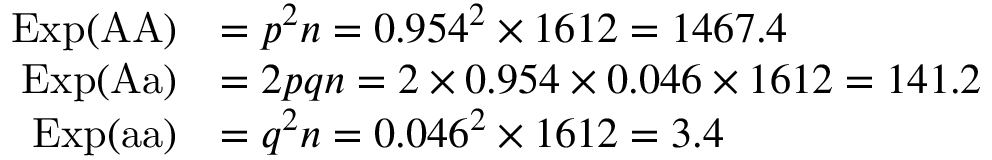Convert formula to latex. <formula><loc_0><loc_0><loc_500><loc_500>{ \begin{array} { r l } { E x p ( { A A } ) } & { = p ^ { 2 } n = 0 . 9 5 4 ^ { 2 } \times 1 6 1 2 = 1 4 6 7 . 4 } \\ { E x p ( { A a } ) } & { = 2 p q n = 2 \times 0 . 9 5 4 \times 0 . 0 4 6 \times 1 6 1 2 = 1 4 1 . 2 } \\ { E x p ( { a a } ) } & { = q ^ { 2 } n = 0 . 0 4 6 ^ { 2 } \times 1 6 1 2 = 3 . 4 } \end{array} }</formula> 